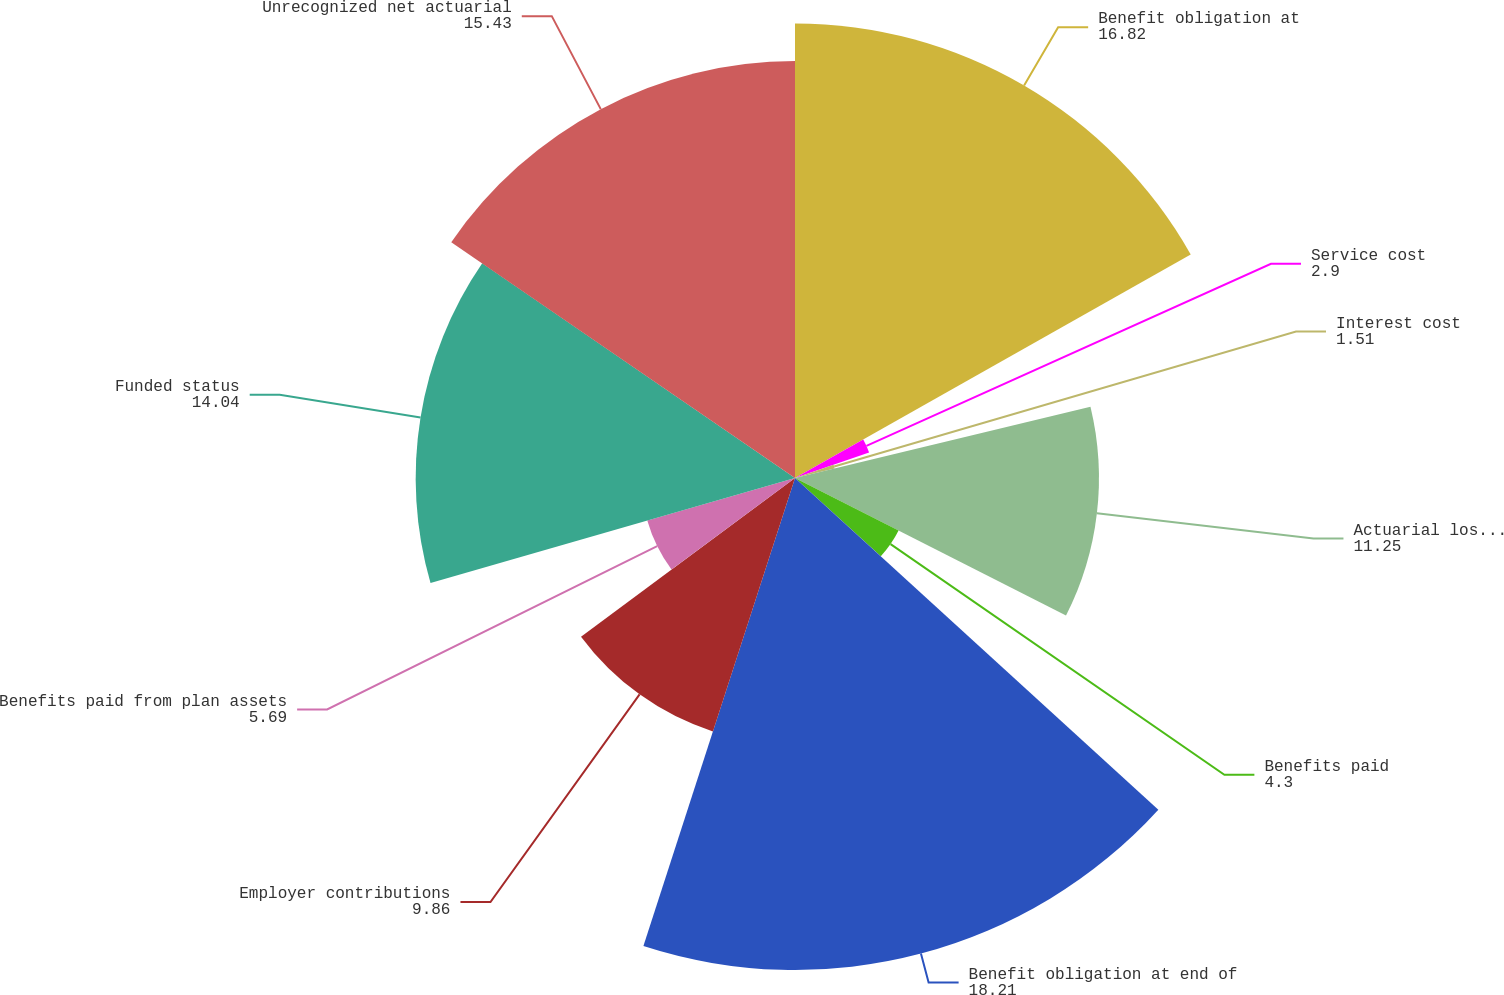Convert chart to OTSL. <chart><loc_0><loc_0><loc_500><loc_500><pie_chart><fcel>Benefit obligation at<fcel>Service cost<fcel>Interest cost<fcel>Actuarial loss (gain)<fcel>Benefits paid<fcel>Benefit obligation at end of<fcel>Employer contributions<fcel>Benefits paid from plan assets<fcel>Funded status<fcel>Unrecognized net actuarial<nl><fcel>16.82%<fcel>2.9%<fcel>1.51%<fcel>11.25%<fcel>4.3%<fcel>18.21%<fcel>9.86%<fcel>5.69%<fcel>14.04%<fcel>15.43%<nl></chart> 